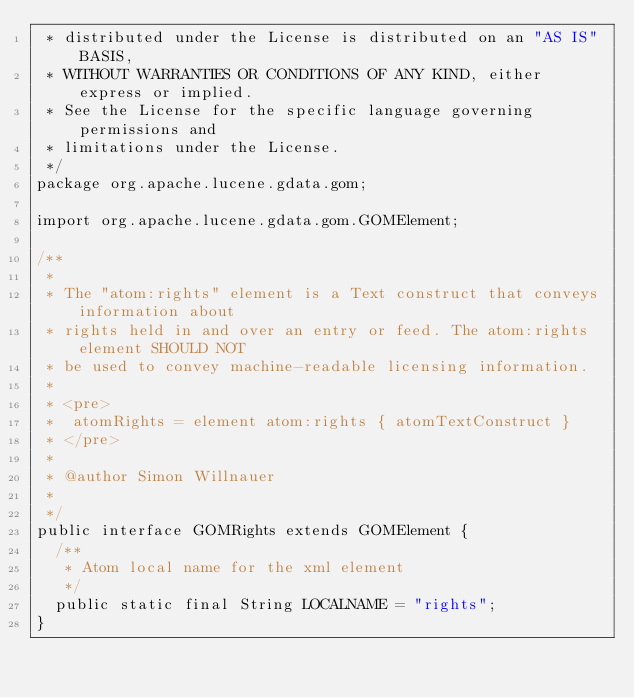Convert code to text. <code><loc_0><loc_0><loc_500><loc_500><_Java_> * distributed under the License is distributed on an "AS IS" BASIS,
 * WITHOUT WARRANTIES OR CONDITIONS OF ANY KIND, either express or implied.
 * See the License for the specific language governing permissions and
 * limitations under the License.
 */
package org.apache.lucene.gdata.gom;

import org.apache.lucene.gdata.gom.GOMElement;

/**
 * 
 * The "atom:rights" element is a Text construct that conveys information about
 * rights held in and over an entry or feed. The atom:rights element SHOULD NOT
 * be used to convey machine-readable licensing information.
 * 
 * <pre>
 *  atomRights = element atom:rights { atomTextConstruct }
 * </pre>
 * 
 * @author Simon Willnauer
 * 
 */
public interface GOMRights extends GOMElement {
	/**
	 * Atom local name for the xml element
	 */
	public static final String LOCALNAME = "rights";
}
</code> 